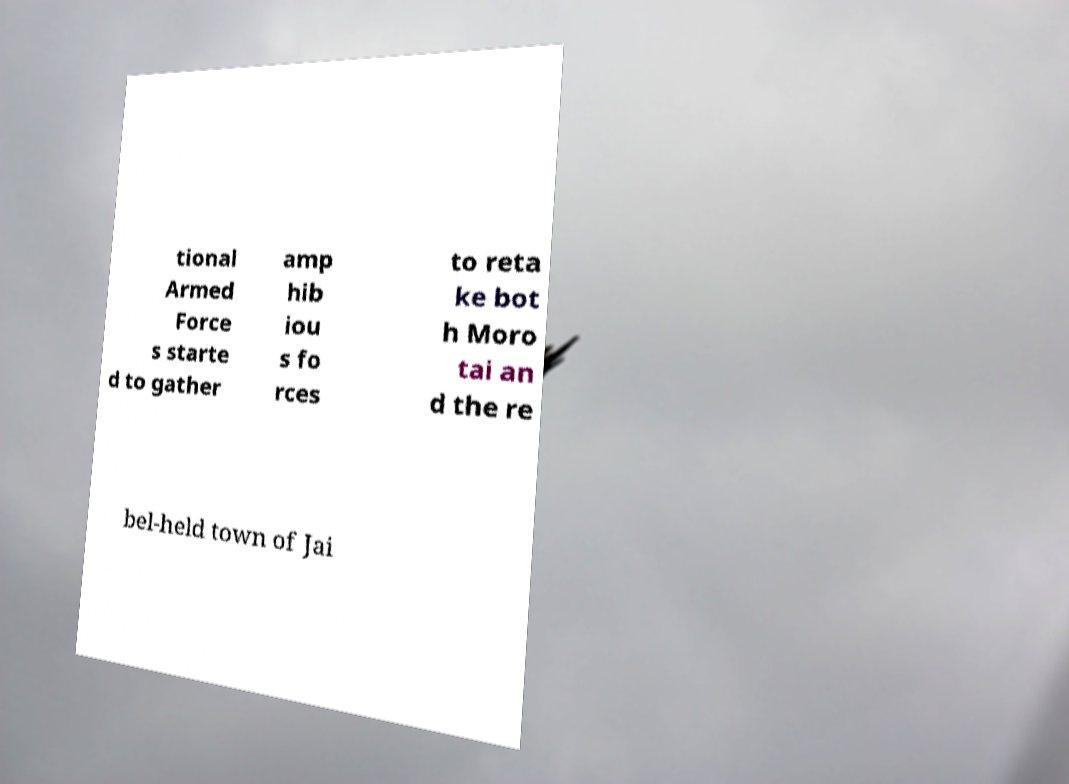What messages or text are displayed in this image? I need them in a readable, typed format. tional Armed Force s starte d to gather amp hib iou s fo rces to reta ke bot h Moro tai an d the re bel-held town of Jai 